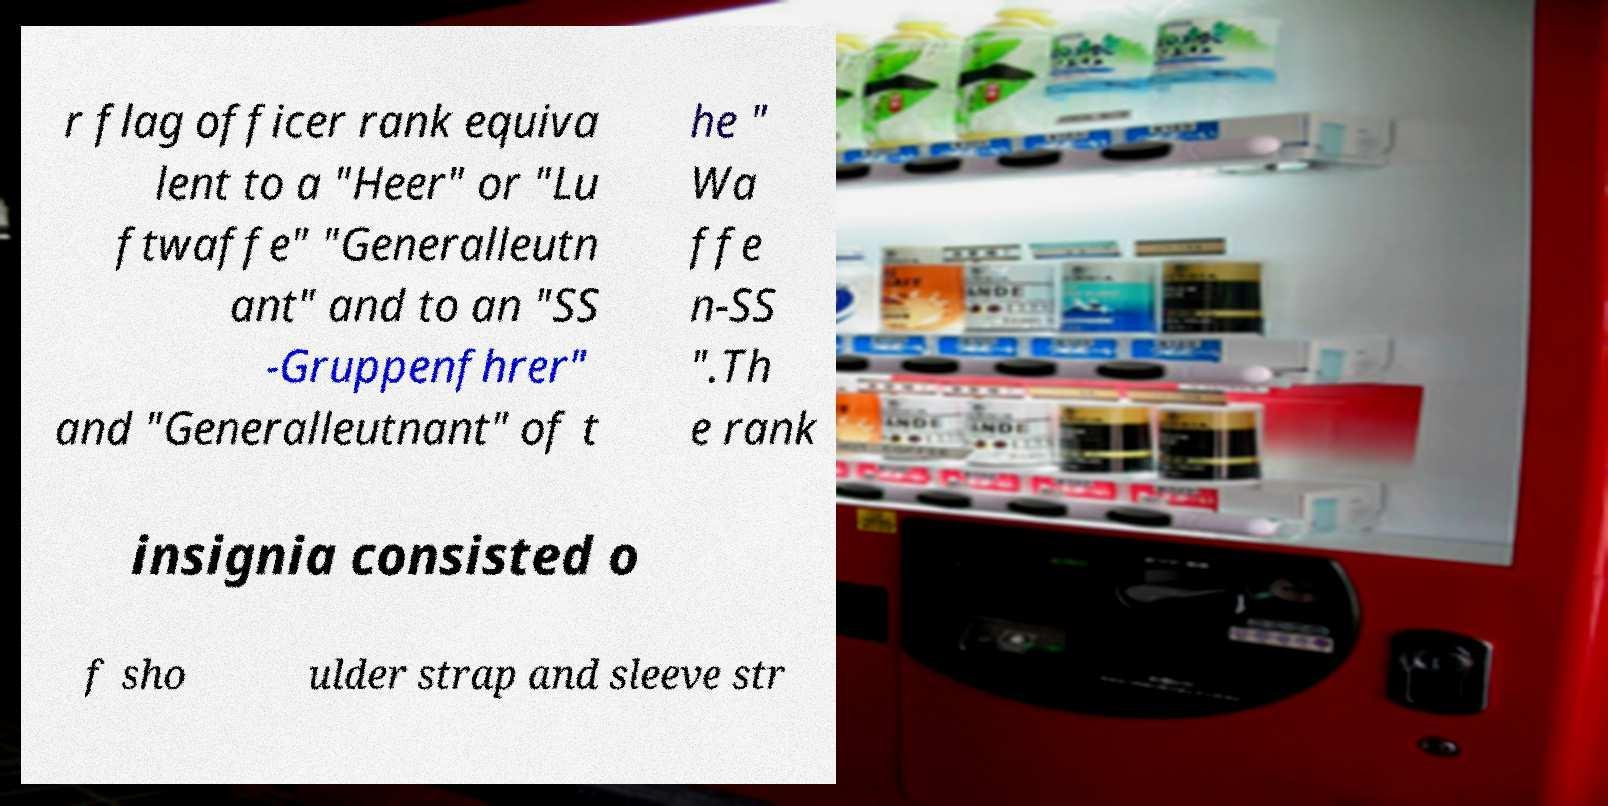For documentation purposes, I need the text within this image transcribed. Could you provide that? r flag officer rank equiva lent to a "Heer" or "Lu ftwaffe" "Generalleutn ant" and to an "SS -Gruppenfhrer" and "Generalleutnant" of t he " Wa ffe n-SS ".Th e rank insignia consisted o f sho ulder strap and sleeve str 